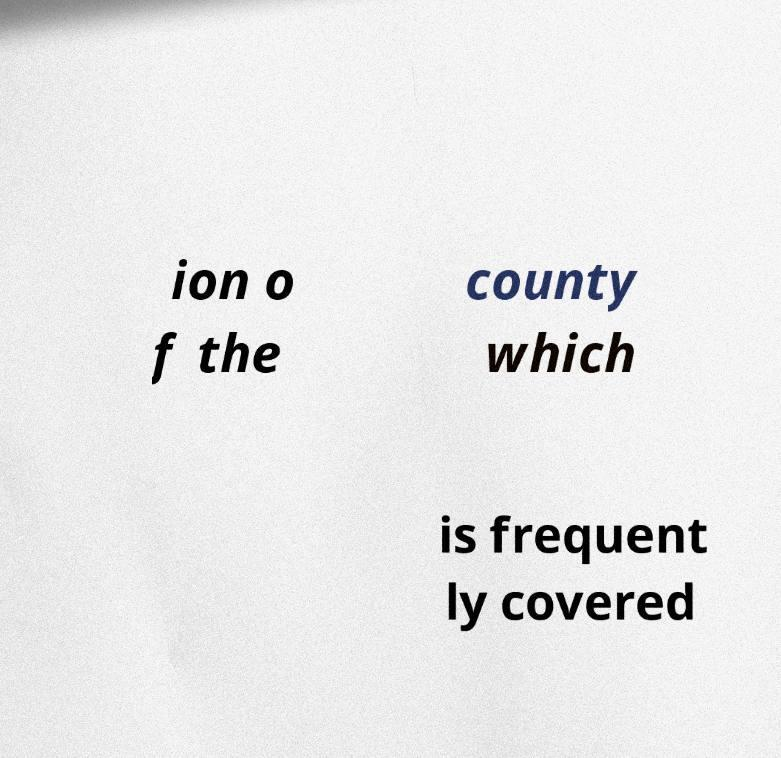There's text embedded in this image that I need extracted. Can you transcribe it verbatim? ion o f the county which is frequent ly covered 